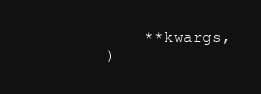Convert code to text. <code><loc_0><loc_0><loc_500><loc_500><_Python_>            **kwargs,
        )
</code> 